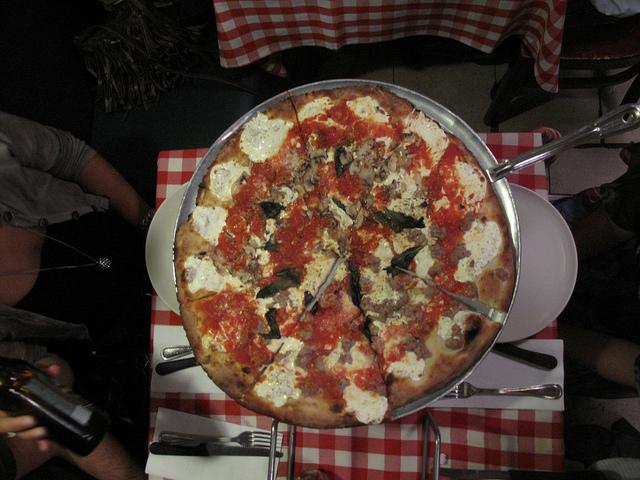Are there utensils present?
Write a very short answer. Yes. Is the pizza cut?
Be succinct. Yes. Where is the pizza?
Keep it brief. On pan. 